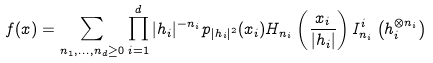<formula> <loc_0><loc_0><loc_500><loc_500>f ( x ) = \sum _ { n _ { 1 } , \dots , n _ { d } \geq 0 } \prod _ { i = 1 } ^ { d } | h _ { i } | ^ { - n _ { i } } p _ { | h _ { i } | ^ { 2 } } ( x _ { i } ) H _ { n _ { i } } \left ( \frac { x _ { i } } { | h _ { i } | } \right ) I ^ { i } _ { n _ { i } } \left ( h _ { i } ^ { \otimes n _ { i } } \right )</formula> 